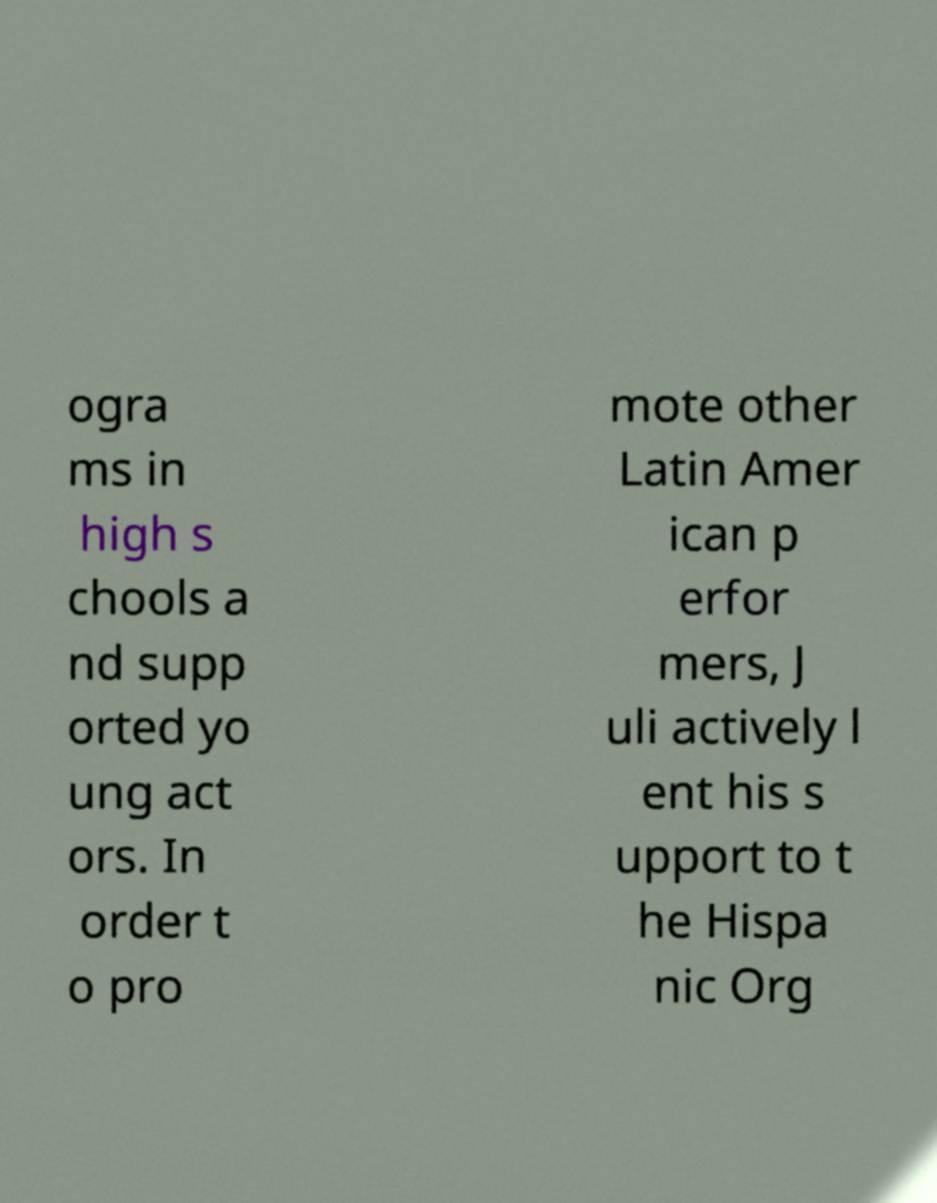What messages or text are displayed in this image? I need them in a readable, typed format. ogra ms in high s chools a nd supp orted yo ung act ors. In order t o pro mote other Latin Amer ican p erfor mers, J uli actively l ent his s upport to t he Hispa nic Org 